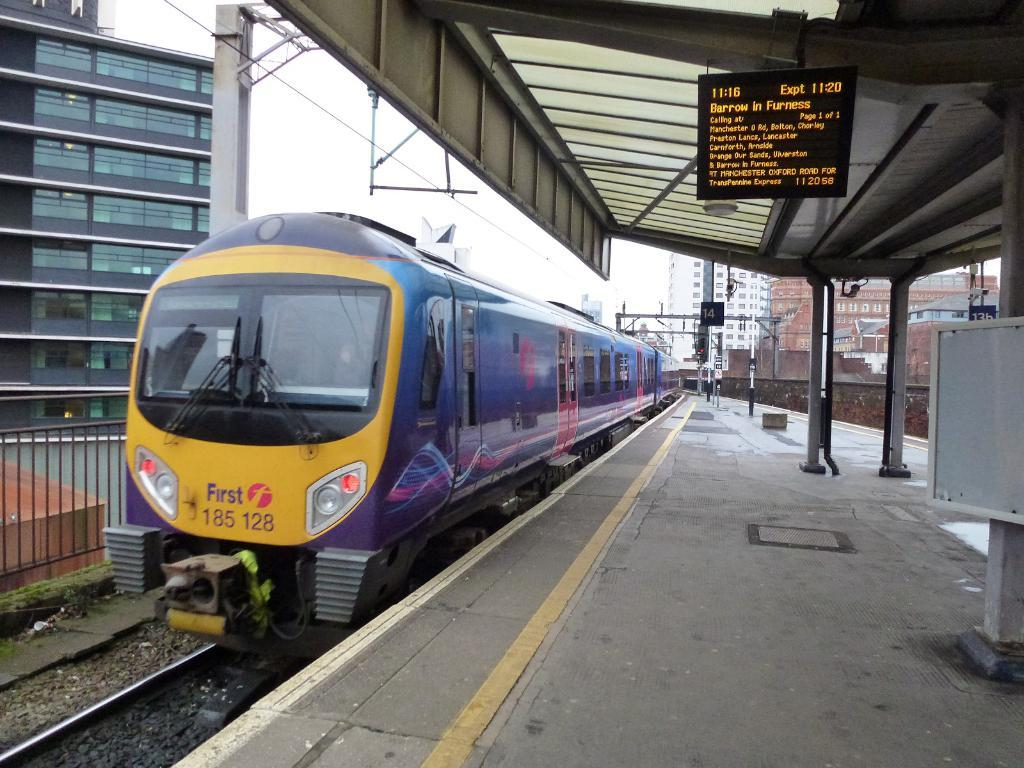<image>
Relay a brief, clear account of the picture shown. The number of this train is 185 128 